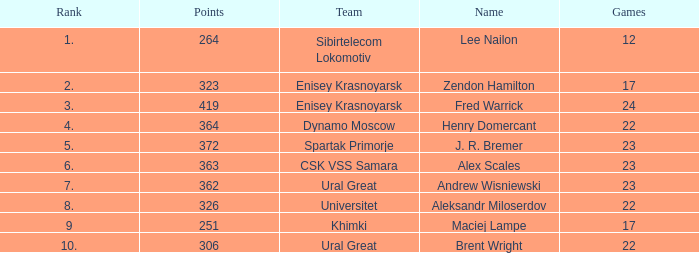What was the game with a rank higher than 2 and a name of zendon hamilton? None. 